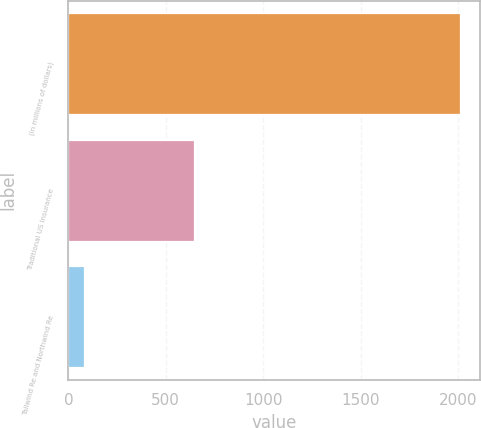<chart> <loc_0><loc_0><loc_500><loc_500><bar_chart><fcel>(in millions of dollars)<fcel>Traditional US Insurance<fcel>Tailwind Re and Northwind Re<nl><fcel>2011<fcel>642.9<fcel>80<nl></chart> 